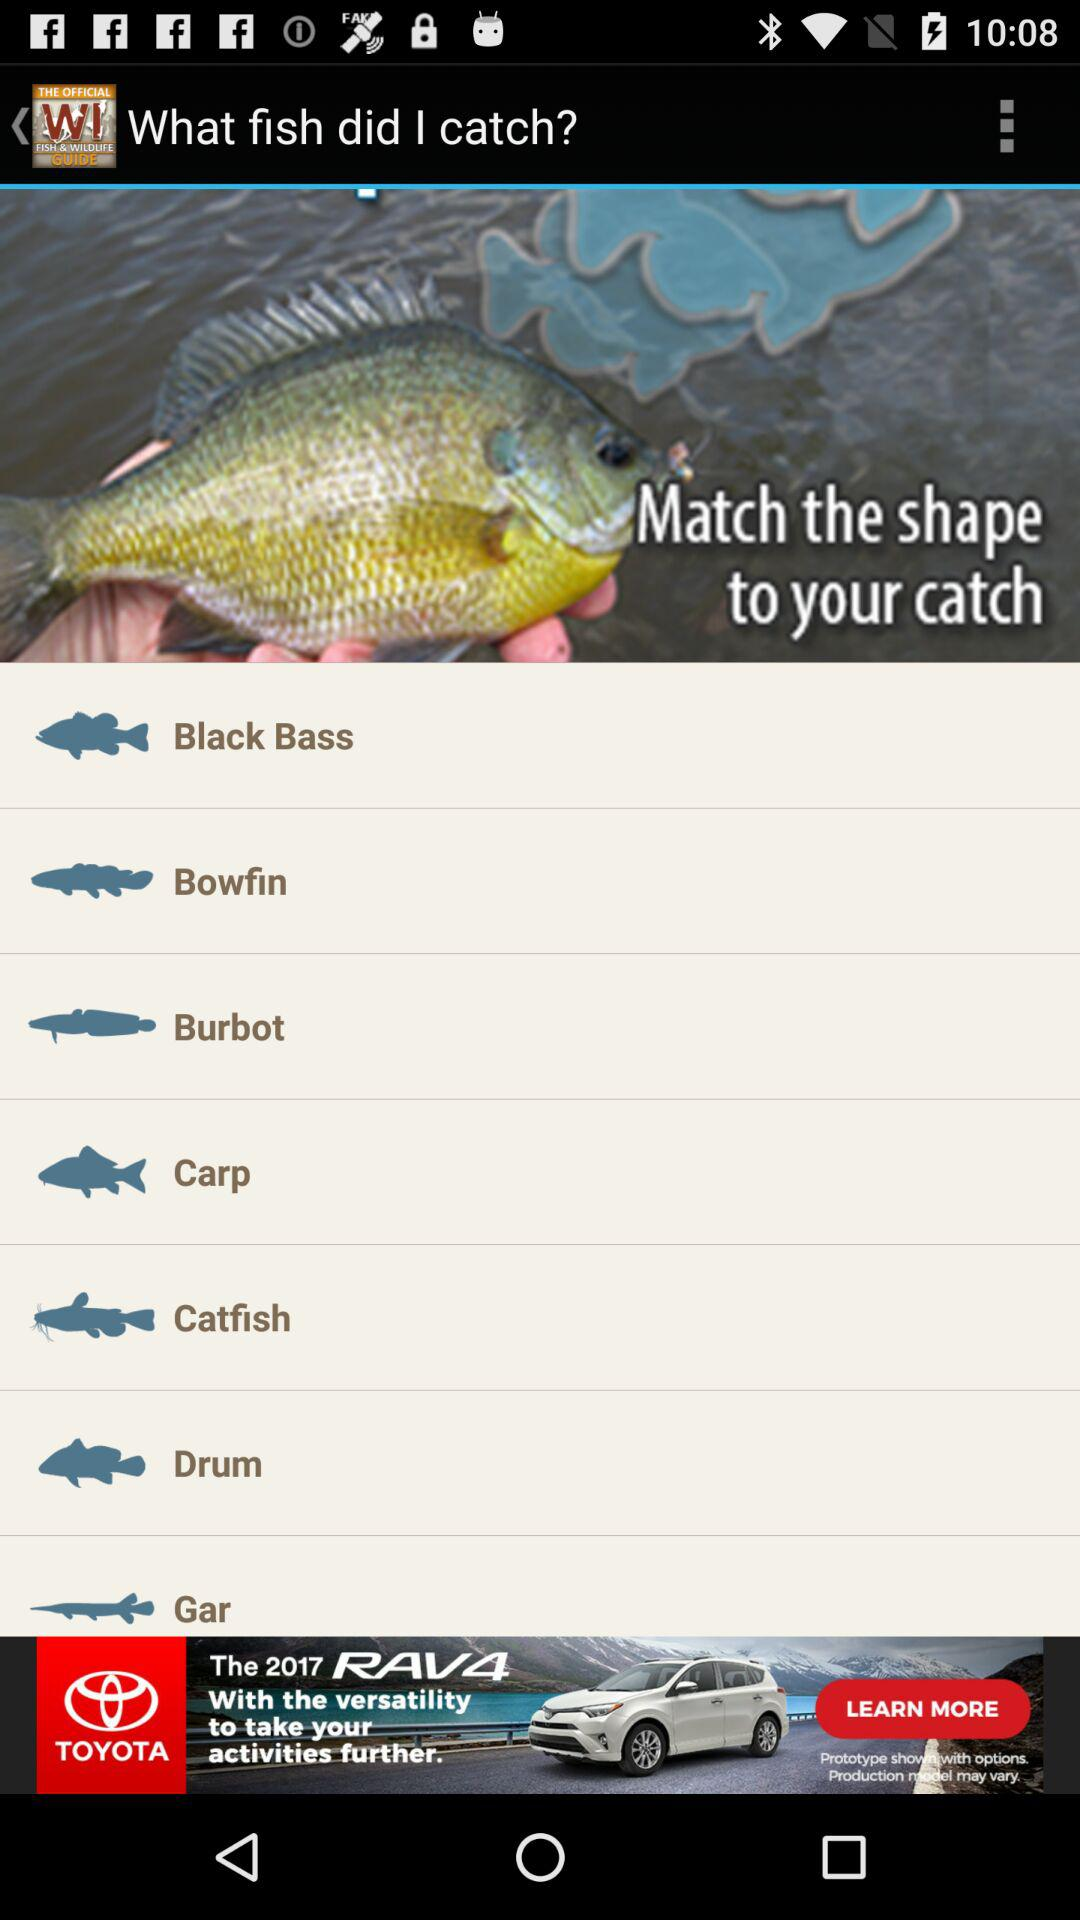What are the available options? The available options are "Black Bass", "Bowfin", "Burbot", "Carp", "Catfish", "Drum" and "Gar". 